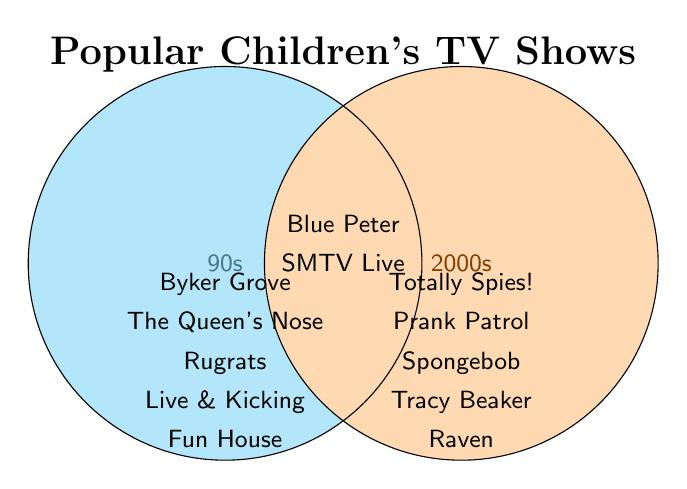How many shows are exclusive to the 90s? Count the shows listed under the 90s section without overlapping into the 2000s or Both sections
Answer: 5 How many shows are there in total across all categories? Sum the shows from all three categories: 5 from the 90s, 5 from the 2000s, and 2 from Both
Answer: 12 Which shows appear in both the 90s and 2000s? Look in the section where both circles overlap to identify shared shows
Answer: Blue Peter, SMTV Live Are there more shows exclusive to the 90s or exclusive to the 2000s? Compare the count of exclusive shows from the 90s (5 shows) with those from the 2000s (5 shows)
Answer: Equal What is the total number of non-overlapping shows? Sum the shows exclusively in the 90s (5 shows) and exclusively in the 2000s (5 shows)
Answer: 10 Which category includes "Tracy Beaker"? Identify the position of "Tracy Beaker" in the diagram
Answer: 2000s How many shows are listed in the "Both" section? Count the shows listed where both circles overlap
Answer: 2 Is "Rugrats" a 90s or a 2000s show? Find "Rugrats" in the diagram and note the category it's listed under
Answer: 90s Do any shows from the 2000s also appear in the 90s? Check if any show listed under the 2000s is also present in the 90s
Answer: No Which section contains "Byker Grove"? Identify the section where "Byker Grove" is listed
Answer: 90s 